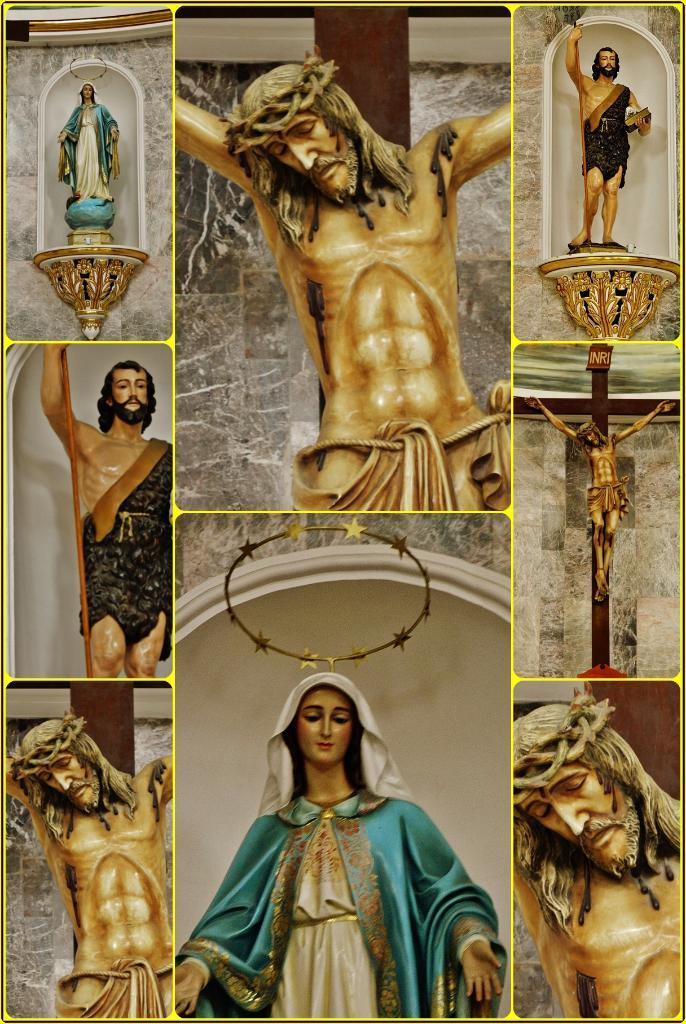What type of artwork is depicted in the image? The image contains a collage of pictures. Can you describe any specific elements within the pictures? There are statues of Jesus in the pictures. What religious symbol is present in the image? A Christianity symbol is present in the image. Are there any other statues besides those of Jesus in the image? Yes, there is a statue of another person in the image. How many girls can be seen playing with the structure in the image? There are no girls or structures present in the image. 